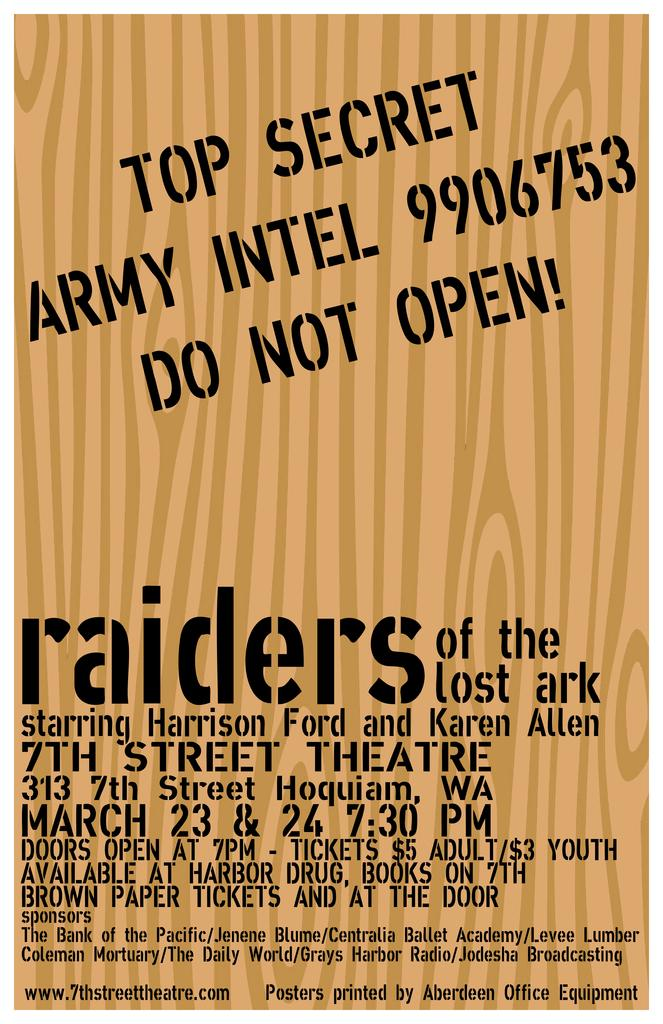<image>
Summarize the visual content of the image. An advertisement for Raiders of the Lost Ark says that the show is at 7:30 pm. 